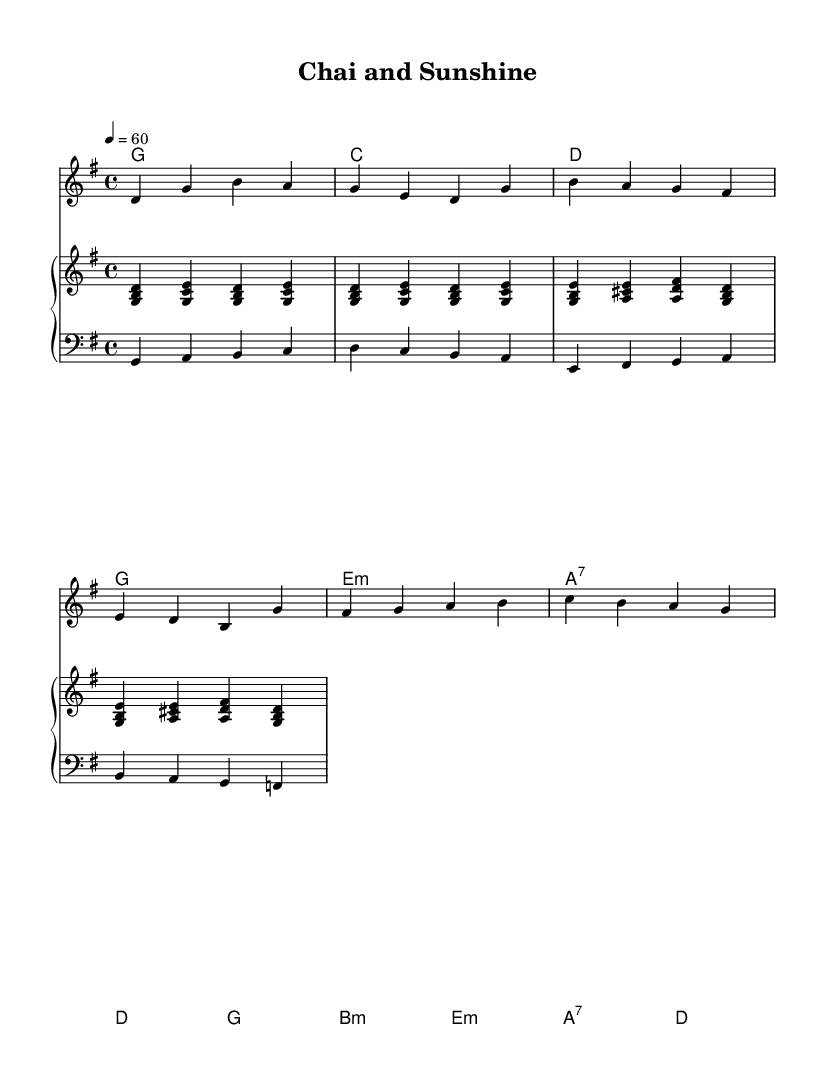What is the key signature of this music? The key signature indicated in the piece has one sharp, which corresponds to the G major key signature.
Answer: G major What is the time signature of this music? The time signature is located at the beginning of the sheet music, indicating four beats per measure, which is represented as 4/4.
Answer: 4/4 What is the tempo marking for the piece? The tempo marking is stated at the beginning as "4 = 60," which means there are 60 beats per minute.
Answer: 60 What is the first chord of the verse? The first chord in the chord section for the verse is indicated and is a G major chord.
Answer: G How many measures are there in the chorus? Counting the measures from the score, there are four unique measures in the chorus section.
Answer: 4 What type of harmonization is used in the piano for the right hand? The right hand piano part consists primarily of triads, which form basic two or three-note chords throughout.
Answer: Triads What emotional quality is typical for blues ballads represented in this piece? The piece invokes a calm and reflective mood, characteristic of slow and contemplative blues ballads that address life's simple pleasures.
Answer: Reflective 